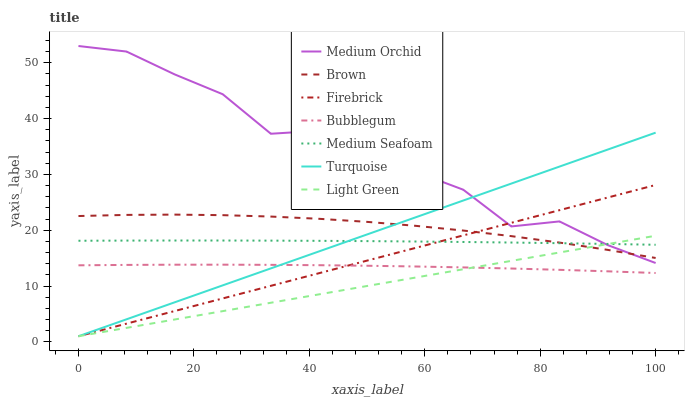Does Light Green have the minimum area under the curve?
Answer yes or no. Yes. Does Medium Orchid have the maximum area under the curve?
Answer yes or no. Yes. Does Turquoise have the minimum area under the curve?
Answer yes or no. No. Does Turquoise have the maximum area under the curve?
Answer yes or no. No. Is Light Green the smoothest?
Answer yes or no. Yes. Is Medium Orchid the roughest?
Answer yes or no. Yes. Is Turquoise the smoothest?
Answer yes or no. No. Is Turquoise the roughest?
Answer yes or no. No. Does Turquoise have the lowest value?
Answer yes or no. Yes. Does Medium Orchid have the lowest value?
Answer yes or no. No. Does Medium Orchid have the highest value?
Answer yes or no. Yes. Does Turquoise have the highest value?
Answer yes or no. No. Is Bubblegum less than Medium Orchid?
Answer yes or no. Yes. Is Brown greater than Bubblegum?
Answer yes or no. Yes. Does Light Green intersect Bubblegum?
Answer yes or no. Yes. Is Light Green less than Bubblegum?
Answer yes or no. No. Is Light Green greater than Bubblegum?
Answer yes or no. No. Does Bubblegum intersect Medium Orchid?
Answer yes or no. No. 